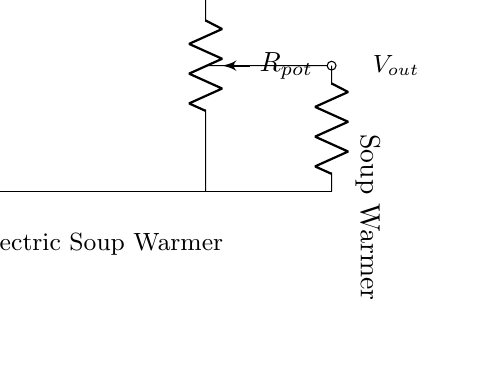What is the role of R1 in this circuit? R1 is a resistor that forms part of the voltage divider. It allows for the division of the input voltage based on the values of R1 and the potentiometer, Rpot.
Answer: Resistor What is Vout taken from? Vout is taken from the midpoint between R1 and the potentiometer (Rpot), where the voltage is divided according to the ratio of these resistors.
Answer: Between R1 and Rpot What happens to Vout if Rpot is adjusted to maximum resistance? If Rpot is adjusted to maximum resistance, Vout will approach Vin because the total resistance of the circuit becomes dominated by Rpot, leading to less voltage drop across R1.
Answer: Approaches Vin Which component controls the temperature of the soup warmer? The component controlling the temperature is the potentiometer, which adjusts the voltage output (Vout) to regulate the soup warmer's power.
Answer: Potentiometer What type of circuit is this? This is a voltage divider circuit, as it divides the input voltage into a lower output voltage by using resistive components.
Answer: Voltage divider 